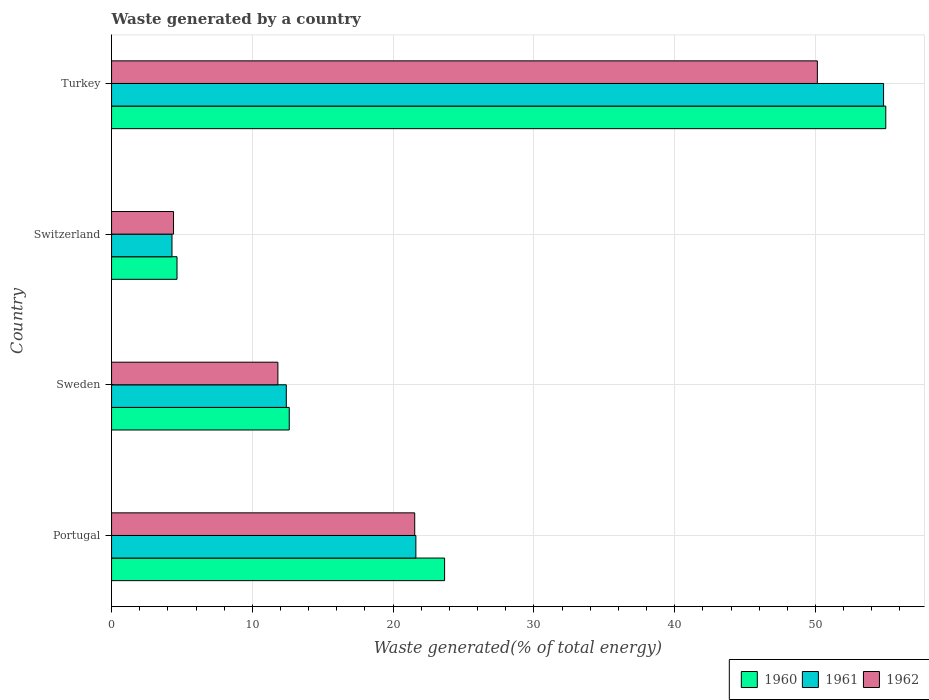How many different coloured bars are there?
Offer a terse response. 3. Are the number of bars per tick equal to the number of legend labels?
Your answer should be very brief. Yes. What is the total waste generated in 1962 in Portugal?
Offer a very short reply. 21.53. Across all countries, what is the maximum total waste generated in 1962?
Provide a succinct answer. 50.13. Across all countries, what is the minimum total waste generated in 1962?
Provide a succinct answer. 4.4. In which country was the total waste generated in 1962 maximum?
Your response must be concise. Turkey. In which country was the total waste generated in 1960 minimum?
Offer a very short reply. Switzerland. What is the total total waste generated in 1961 in the graph?
Provide a short and direct response. 93.16. What is the difference between the total waste generated in 1960 in Portugal and that in Switzerland?
Give a very brief answer. 19.01. What is the difference between the total waste generated in 1960 in Turkey and the total waste generated in 1962 in Switzerland?
Your answer should be compact. 50.59. What is the average total waste generated in 1961 per country?
Give a very brief answer. 23.29. What is the difference between the total waste generated in 1960 and total waste generated in 1961 in Sweden?
Make the answer very short. 0.21. In how many countries, is the total waste generated in 1960 greater than 4 %?
Provide a short and direct response. 4. What is the ratio of the total waste generated in 1960 in Switzerland to that in Turkey?
Provide a short and direct response. 0.08. Is the difference between the total waste generated in 1960 in Portugal and Switzerland greater than the difference between the total waste generated in 1961 in Portugal and Switzerland?
Your answer should be very brief. Yes. What is the difference between the highest and the second highest total waste generated in 1961?
Ensure brevity in your answer.  33.22. What is the difference between the highest and the lowest total waste generated in 1961?
Your answer should be very brief. 50.55. Is the sum of the total waste generated in 1960 in Sweden and Switzerland greater than the maximum total waste generated in 1961 across all countries?
Provide a short and direct response. No. What does the 2nd bar from the top in Sweden represents?
Give a very brief answer. 1961. Is it the case that in every country, the sum of the total waste generated in 1961 and total waste generated in 1962 is greater than the total waste generated in 1960?
Offer a very short reply. Yes. How many bars are there?
Provide a short and direct response. 12. How many countries are there in the graph?
Ensure brevity in your answer.  4. What is the difference between two consecutive major ticks on the X-axis?
Keep it short and to the point. 10. Does the graph contain grids?
Offer a terse response. Yes. How are the legend labels stacked?
Your answer should be compact. Horizontal. What is the title of the graph?
Ensure brevity in your answer.  Waste generated by a country. What is the label or title of the X-axis?
Your answer should be very brief. Waste generated(% of total energy). What is the label or title of the Y-axis?
Offer a terse response. Country. What is the Waste generated(% of total energy) of 1960 in Portugal?
Ensure brevity in your answer.  23.66. What is the Waste generated(% of total energy) in 1961 in Portugal?
Your answer should be very brief. 21.62. What is the Waste generated(% of total energy) of 1962 in Portugal?
Give a very brief answer. 21.53. What is the Waste generated(% of total energy) of 1960 in Sweden?
Provide a succinct answer. 12.62. What is the Waste generated(% of total energy) in 1961 in Sweden?
Offer a very short reply. 12.41. What is the Waste generated(% of total energy) of 1962 in Sweden?
Provide a succinct answer. 11.82. What is the Waste generated(% of total energy) of 1960 in Switzerland?
Make the answer very short. 4.65. What is the Waste generated(% of total energy) of 1961 in Switzerland?
Offer a terse response. 4.29. What is the Waste generated(% of total energy) of 1962 in Switzerland?
Offer a very short reply. 4.4. What is the Waste generated(% of total energy) in 1960 in Turkey?
Give a very brief answer. 54.99. What is the Waste generated(% of total energy) of 1961 in Turkey?
Offer a terse response. 54.84. What is the Waste generated(% of total energy) in 1962 in Turkey?
Your answer should be very brief. 50.13. Across all countries, what is the maximum Waste generated(% of total energy) of 1960?
Your answer should be very brief. 54.99. Across all countries, what is the maximum Waste generated(% of total energy) in 1961?
Offer a very short reply. 54.84. Across all countries, what is the maximum Waste generated(% of total energy) of 1962?
Offer a terse response. 50.13. Across all countries, what is the minimum Waste generated(% of total energy) in 1960?
Make the answer very short. 4.65. Across all countries, what is the minimum Waste generated(% of total energy) of 1961?
Your response must be concise. 4.29. Across all countries, what is the minimum Waste generated(% of total energy) in 1962?
Give a very brief answer. 4.4. What is the total Waste generated(% of total energy) of 1960 in the graph?
Ensure brevity in your answer.  95.92. What is the total Waste generated(% of total energy) of 1961 in the graph?
Your answer should be very brief. 93.16. What is the total Waste generated(% of total energy) of 1962 in the graph?
Your answer should be very brief. 87.89. What is the difference between the Waste generated(% of total energy) in 1960 in Portugal and that in Sweden?
Ensure brevity in your answer.  11.03. What is the difference between the Waste generated(% of total energy) in 1961 in Portugal and that in Sweden?
Your answer should be compact. 9.2. What is the difference between the Waste generated(% of total energy) of 1962 in Portugal and that in Sweden?
Ensure brevity in your answer.  9.72. What is the difference between the Waste generated(% of total energy) of 1960 in Portugal and that in Switzerland?
Your response must be concise. 19.01. What is the difference between the Waste generated(% of total energy) of 1961 in Portugal and that in Switzerland?
Make the answer very short. 17.32. What is the difference between the Waste generated(% of total energy) in 1962 in Portugal and that in Switzerland?
Offer a very short reply. 17.13. What is the difference between the Waste generated(% of total energy) in 1960 in Portugal and that in Turkey?
Your response must be concise. -31.34. What is the difference between the Waste generated(% of total energy) of 1961 in Portugal and that in Turkey?
Provide a succinct answer. -33.22. What is the difference between the Waste generated(% of total energy) in 1962 in Portugal and that in Turkey?
Offer a very short reply. -28.6. What is the difference between the Waste generated(% of total energy) of 1960 in Sweden and that in Switzerland?
Provide a short and direct response. 7.97. What is the difference between the Waste generated(% of total energy) of 1961 in Sweden and that in Switzerland?
Provide a succinct answer. 8.12. What is the difference between the Waste generated(% of total energy) of 1962 in Sweden and that in Switzerland?
Provide a succinct answer. 7.41. What is the difference between the Waste generated(% of total energy) in 1960 in Sweden and that in Turkey?
Provide a succinct answer. -42.37. What is the difference between the Waste generated(% of total energy) in 1961 in Sweden and that in Turkey?
Your answer should be very brief. -42.43. What is the difference between the Waste generated(% of total energy) in 1962 in Sweden and that in Turkey?
Your response must be concise. -38.32. What is the difference between the Waste generated(% of total energy) in 1960 in Switzerland and that in Turkey?
Your answer should be very brief. -50.34. What is the difference between the Waste generated(% of total energy) in 1961 in Switzerland and that in Turkey?
Your answer should be very brief. -50.55. What is the difference between the Waste generated(% of total energy) of 1962 in Switzerland and that in Turkey?
Offer a very short reply. -45.73. What is the difference between the Waste generated(% of total energy) in 1960 in Portugal and the Waste generated(% of total energy) in 1961 in Sweden?
Give a very brief answer. 11.24. What is the difference between the Waste generated(% of total energy) in 1960 in Portugal and the Waste generated(% of total energy) in 1962 in Sweden?
Ensure brevity in your answer.  11.84. What is the difference between the Waste generated(% of total energy) in 1961 in Portugal and the Waste generated(% of total energy) in 1962 in Sweden?
Offer a terse response. 9.8. What is the difference between the Waste generated(% of total energy) of 1960 in Portugal and the Waste generated(% of total energy) of 1961 in Switzerland?
Your response must be concise. 19.36. What is the difference between the Waste generated(% of total energy) of 1960 in Portugal and the Waste generated(% of total energy) of 1962 in Switzerland?
Make the answer very short. 19.25. What is the difference between the Waste generated(% of total energy) of 1961 in Portugal and the Waste generated(% of total energy) of 1962 in Switzerland?
Offer a terse response. 17.21. What is the difference between the Waste generated(% of total energy) of 1960 in Portugal and the Waste generated(% of total energy) of 1961 in Turkey?
Ensure brevity in your answer.  -31.18. What is the difference between the Waste generated(% of total energy) of 1960 in Portugal and the Waste generated(% of total energy) of 1962 in Turkey?
Ensure brevity in your answer.  -26.48. What is the difference between the Waste generated(% of total energy) of 1961 in Portugal and the Waste generated(% of total energy) of 1962 in Turkey?
Provide a short and direct response. -28.52. What is the difference between the Waste generated(% of total energy) of 1960 in Sweden and the Waste generated(% of total energy) of 1961 in Switzerland?
Ensure brevity in your answer.  8.33. What is the difference between the Waste generated(% of total energy) of 1960 in Sweden and the Waste generated(% of total energy) of 1962 in Switzerland?
Keep it short and to the point. 8.22. What is the difference between the Waste generated(% of total energy) of 1961 in Sweden and the Waste generated(% of total energy) of 1962 in Switzerland?
Your answer should be compact. 8.01. What is the difference between the Waste generated(% of total energy) of 1960 in Sweden and the Waste generated(% of total energy) of 1961 in Turkey?
Make the answer very short. -42.22. What is the difference between the Waste generated(% of total energy) of 1960 in Sweden and the Waste generated(% of total energy) of 1962 in Turkey?
Give a very brief answer. -37.51. What is the difference between the Waste generated(% of total energy) of 1961 in Sweden and the Waste generated(% of total energy) of 1962 in Turkey?
Your response must be concise. -37.72. What is the difference between the Waste generated(% of total energy) in 1960 in Switzerland and the Waste generated(% of total energy) in 1961 in Turkey?
Keep it short and to the point. -50.19. What is the difference between the Waste generated(% of total energy) in 1960 in Switzerland and the Waste generated(% of total energy) in 1962 in Turkey?
Make the answer very short. -45.48. What is the difference between the Waste generated(% of total energy) in 1961 in Switzerland and the Waste generated(% of total energy) in 1962 in Turkey?
Your response must be concise. -45.84. What is the average Waste generated(% of total energy) of 1960 per country?
Your answer should be very brief. 23.98. What is the average Waste generated(% of total energy) in 1961 per country?
Give a very brief answer. 23.29. What is the average Waste generated(% of total energy) of 1962 per country?
Make the answer very short. 21.97. What is the difference between the Waste generated(% of total energy) of 1960 and Waste generated(% of total energy) of 1961 in Portugal?
Offer a very short reply. 2.04. What is the difference between the Waste generated(% of total energy) in 1960 and Waste generated(% of total energy) in 1962 in Portugal?
Provide a succinct answer. 2.12. What is the difference between the Waste generated(% of total energy) of 1961 and Waste generated(% of total energy) of 1962 in Portugal?
Give a very brief answer. 0.08. What is the difference between the Waste generated(% of total energy) of 1960 and Waste generated(% of total energy) of 1961 in Sweden?
Offer a terse response. 0.21. What is the difference between the Waste generated(% of total energy) in 1960 and Waste generated(% of total energy) in 1962 in Sweden?
Your answer should be compact. 0.81. What is the difference between the Waste generated(% of total energy) of 1961 and Waste generated(% of total energy) of 1962 in Sweden?
Give a very brief answer. 0.6. What is the difference between the Waste generated(% of total energy) of 1960 and Waste generated(% of total energy) of 1961 in Switzerland?
Provide a succinct answer. 0.36. What is the difference between the Waste generated(% of total energy) of 1960 and Waste generated(% of total energy) of 1962 in Switzerland?
Provide a short and direct response. 0.25. What is the difference between the Waste generated(% of total energy) of 1961 and Waste generated(% of total energy) of 1962 in Switzerland?
Your answer should be very brief. -0.11. What is the difference between the Waste generated(% of total energy) of 1960 and Waste generated(% of total energy) of 1961 in Turkey?
Provide a short and direct response. 0.16. What is the difference between the Waste generated(% of total energy) in 1960 and Waste generated(% of total energy) in 1962 in Turkey?
Your answer should be compact. 4.86. What is the difference between the Waste generated(% of total energy) in 1961 and Waste generated(% of total energy) in 1962 in Turkey?
Your answer should be compact. 4.7. What is the ratio of the Waste generated(% of total energy) of 1960 in Portugal to that in Sweden?
Keep it short and to the point. 1.87. What is the ratio of the Waste generated(% of total energy) in 1961 in Portugal to that in Sweden?
Give a very brief answer. 1.74. What is the ratio of the Waste generated(% of total energy) of 1962 in Portugal to that in Sweden?
Provide a short and direct response. 1.82. What is the ratio of the Waste generated(% of total energy) in 1960 in Portugal to that in Switzerland?
Ensure brevity in your answer.  5.09. What is the ratio of the Waste generated(% of total energy) of 1961 in Portugal to that in Switzerland?
Provide a short and direct response. 5.04. What is the ratio of the Waste generated(% of total energy) in 1962 in Portugal to that in Switzerland?
Give a very brief answer. 4.89. What is the ratio of the Waste generated(% of total energy) in 1960 in Portugal to that in Turkey?
Offer a very short reply. 0.43. What is the ratio of the Waste generated(% of total energy) in 1961 in Portugal to that in Turkey?
Your answer should be very brief. 0.39. What is the ratio of the Waste generated(% of total energy) of 1962 in Portugal to that in Turkey?
Your answer should be compact. 0.43. What is the ratio of the Waste generated(% of total energy) of 1960 in Sweden to that in Switzerland?
Offer a very short reply. 2.71. What is the ratio of the Waste generated(% of total energy) in 1961 in Sweden to that in Switzerland?
Your answer should be very brief. 2.89. What is the ratio of the Waste generated(% of total energy) of 1962 in Sweden to that in Switzerland?
Give a very brief answer. 2.68. What is the ratio of the Waste generated(% of total energy) of 1960 in Sweden to that in Turkey?
Ensure brevity in your answer.  0.23. What is the ratio of the Waste generated(% of total energy) in 1961 in Sweden to that in Turkey?
Give a very brief answer. 0.23. What is the ratio of the Waste generated(% of total energy) in 1962 in Sweden to that in Turkey?
Provide a short and direct response. 0.24. What is the ratio of the Waste generated(% of total energy) in 1960 in Switzerland to that in Turkey?
Offer a terse response. 0.08. What is the ratio of the Waste generated(% of total energy) in 1961 in Switzerland to that in Turkey?
Make the answer very short. 0.08. What is the ratio of the Waste generated(% of total energy) in 1962 in Switzerland to that in Turkey?
Your response must be concise. 0.09. What is the difference between the highest and the second highest Waste generated(% of total energy) of 1960?
Ensure brevity in your answer.  31.34. What is the difference between the highest and the second highest Waste generated(% of total energy) in 1961?
Provide a short and direct response. 33.22. What is the difference between the highest and the second highest Waste generated(% of total energy) in 1962?
Ensure brevity in your answer.  28.6. What is the difference between the highest and the lowest Waste generated(% of total energy) of 1960?
Your response must be concise. 50.34. What is the difference between the highest and the lowest Waste generated(% of total energy) of 1961?
Your response must be concise. 50.55. What is the difference between the highest and the lowest Waste generated(% of total energy) of 1962?
Offer a terse response. 45.73. 